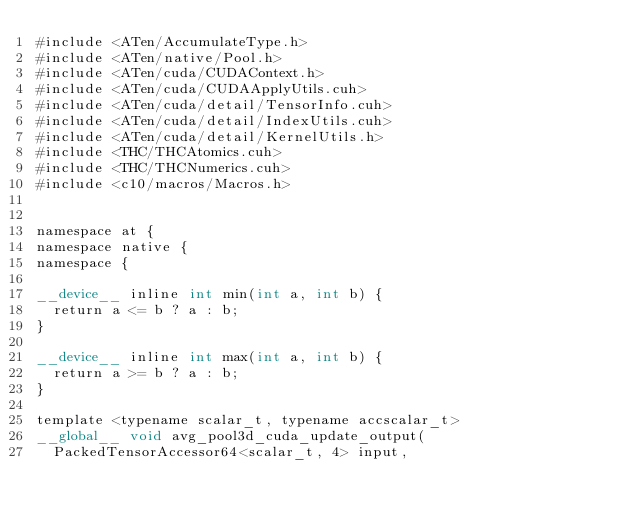Convert code to text. <code><loc_0><loc_0><loc_500><loc_500><_Cuda_>#include <ATen/AccumulateType.h>
#include <ATen/native/Pool.h>
#include <ATen/cuda/CUDAContext.h>
#include <ATen/cuda/CUDAApplyUtils.cuh>
#include <ATen/cuda/detail/TensorInfo.cuh>
#include <ATen/cuda/detail/IndexUtils.cuh>
#include <ATen/cuda/detail/KernelUtils.h>
#include <THC/THCAtomics.cuh>
#include <THC/THCNumerics.cuh>
#include <c10/macros/Macros.h>


namespace at {
namespace native {
namespace {

__device__ inline int min(int a, int b) {
  return a <= b ? a : b;
}

__device__ inline int max(int a, int b) {
  return a >= b ? a : b;
}

template <typename scalar_t, typename accscalar_t>
__global__ void avg_pool3d_cuda_update_output(
  PackedTensorAccessor64<scalar_t, 4> input,</code> 